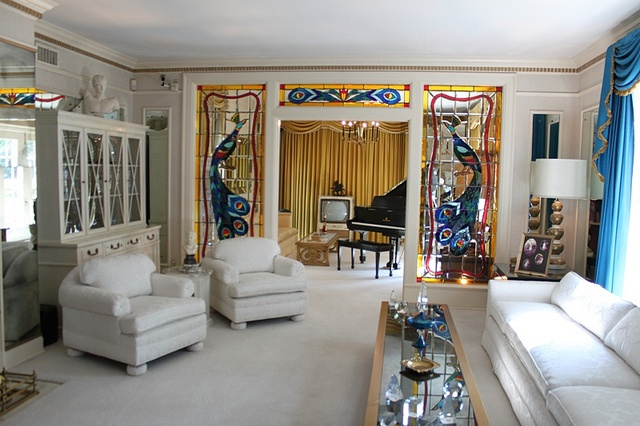Describe the objects in this image and their specific colors. I can see couch in gray, white, darkgray, and lightgray tones, chair in gray, darkgray, and black tones, chair in gray, darkgray, and lightgray tones, couch in gray, darkgray, and lightgray tones, and tv in gray, darkgray, and black tones in this image. 